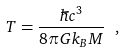<formula> <loc_0><loc_0><loc_500><loc_500>T = { \frac { \hbar { c } ^ { 3 } } { 8 \pi G k _ { B } M } } \ ,</formula> 